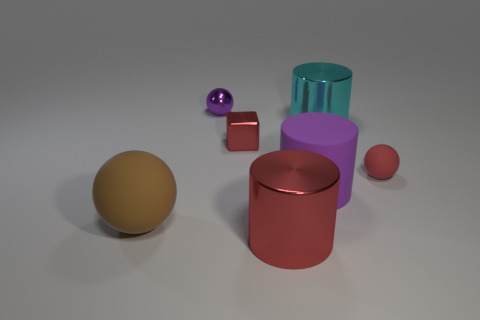What is the lighting condition in the scene? The scene is softly lit from above, casting gentle shadows beneath the objects. The lighting doesn't produce strong highlights, indicating a diffused light source, possibly creating a studio-like atmosphere. Does the lighting affect the color appearance of the objects? Indeed, the diffused light allows the true colors of the objects to be displayed with minimal distortion or over-saturation, providing a clear view of their hues and material characteristics. 